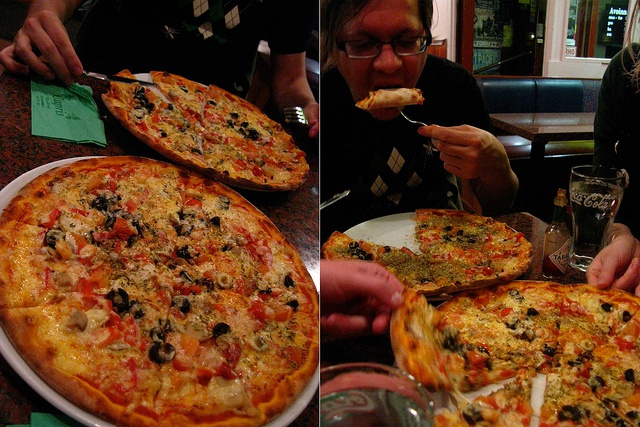Describe the objects in this image and their specific colors. I can see pizza in black, brown, maroon, and salmon tones, dining table in black, brown, and maroon tones, people in black, maroon, and brown tones, pizza in black, brown, and maroon tones, and people in black, maroon, and brown tones in this image. 